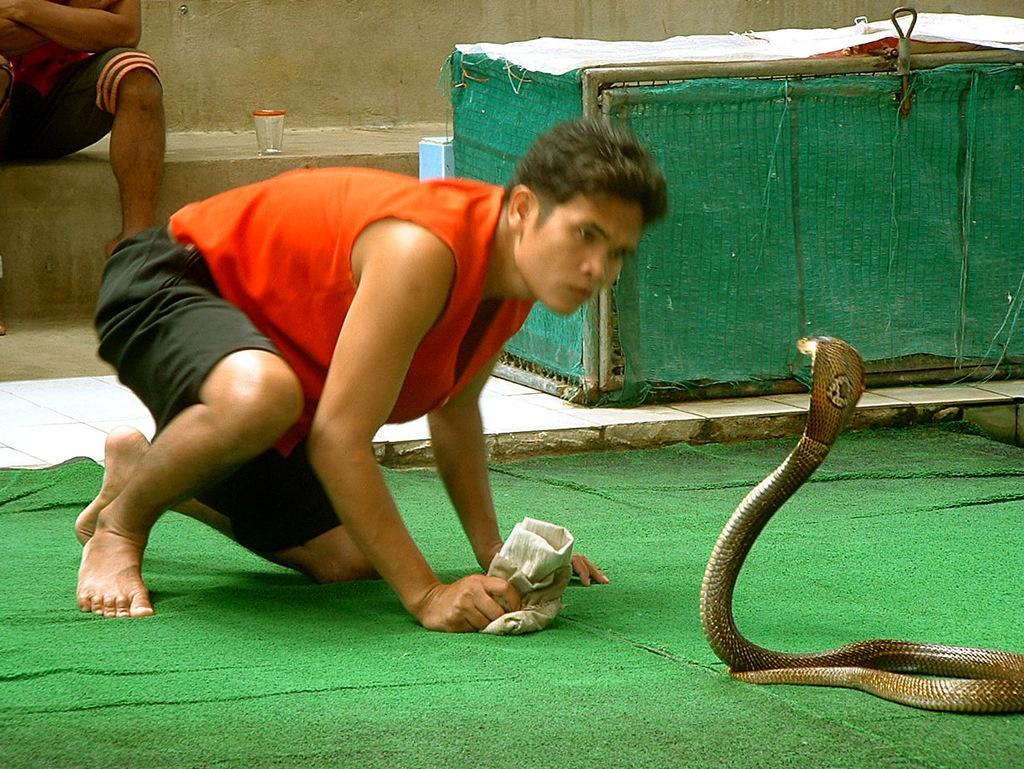Describe this image in one or two sentences. In the picture we can see a green color floor mat on it, we can see a man sitting on a knee and in front of him we can see a snake and a man is watching it and behind him we can see a person sitting near the wall and beside him we can see a box which is covered with green color cloth to it. 